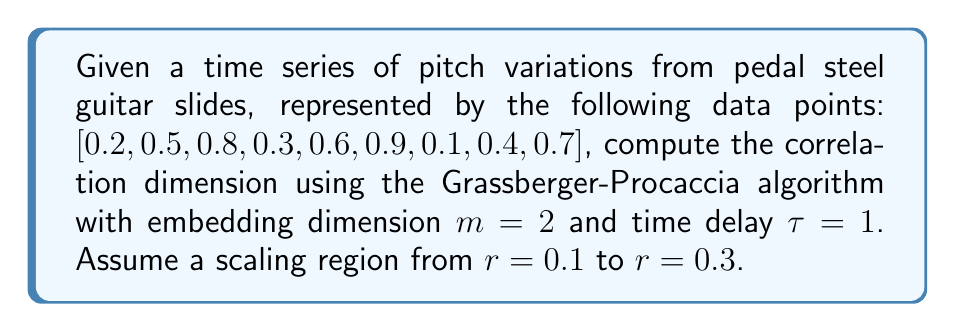Provide a solution to this math problem. To compute the correlation dimension, we'll follow these steps:

1. Construct the phase space vectors:
   $$X_i = (x_i, x_{i+\tau}) = (x_i, x_{i+1})$$
   Resulting in: [(0.2, 0.5), (0.5, 0.8), (0.8, 0.3), (0.3, 0.6), (0.6, 0.9), (0.9, 0.1), (0.1, 0.4), (0.4, 0.7)]

2. Calculate the correlation sum $C(r)$ for different $r$ values:
   $$C(r) = \frac{2}{N(N-1)} \sum_{i=1}^{N} \sum_{j=i+1}^{N} H(r - ||X_i - X_j||)$$
   where $H$ is the Heaviside step function and $N$ is the number of vectors.

3. For $r = 0.1, 0.2, 0.3$, compute $C(r)$:
   $C(0.1) \approx 0.0357$
   $C(0.2) \approx 0.1786$
   $C(0.3) \approx 0.3929$

4. Plot $\log(C(r))$ vs $\log(r)$:
   $$\log(0.0357) \approx -3.3327$$
   $$\log(0.1786) \approx -1.7228$$
   $$\log(0.3929) \approx -0.9344$$
   $$\log(0.1) \approx -2.3026$$
   $$\log(0.2) \approx -1.6094$$
   $$\log(0.3) \approx -1.2040$$

5. Calculate the slope of the linear fit:
   $$D_2 = \frac{\log(C(r_2)) - \log(C(r_1))}{\log(r_2) - \log(r_1)}$$
   $$D_2 \approx \frac{-0.9344 - (-3.3327)}{-1.2040 - (-2.3026)} = \frac{2.3983}{1.0986} \approx 2.1830$$

The correlation dimension is approximately 2.1830.
Answer: 2.1830 